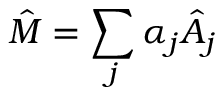Convert formula to latex. <formula><loc_0><loc_0><loc_500><loc_500>\hat { M } = \sum _ { j } \alpha _ { j } \hat { A } _ { j }</formula> 